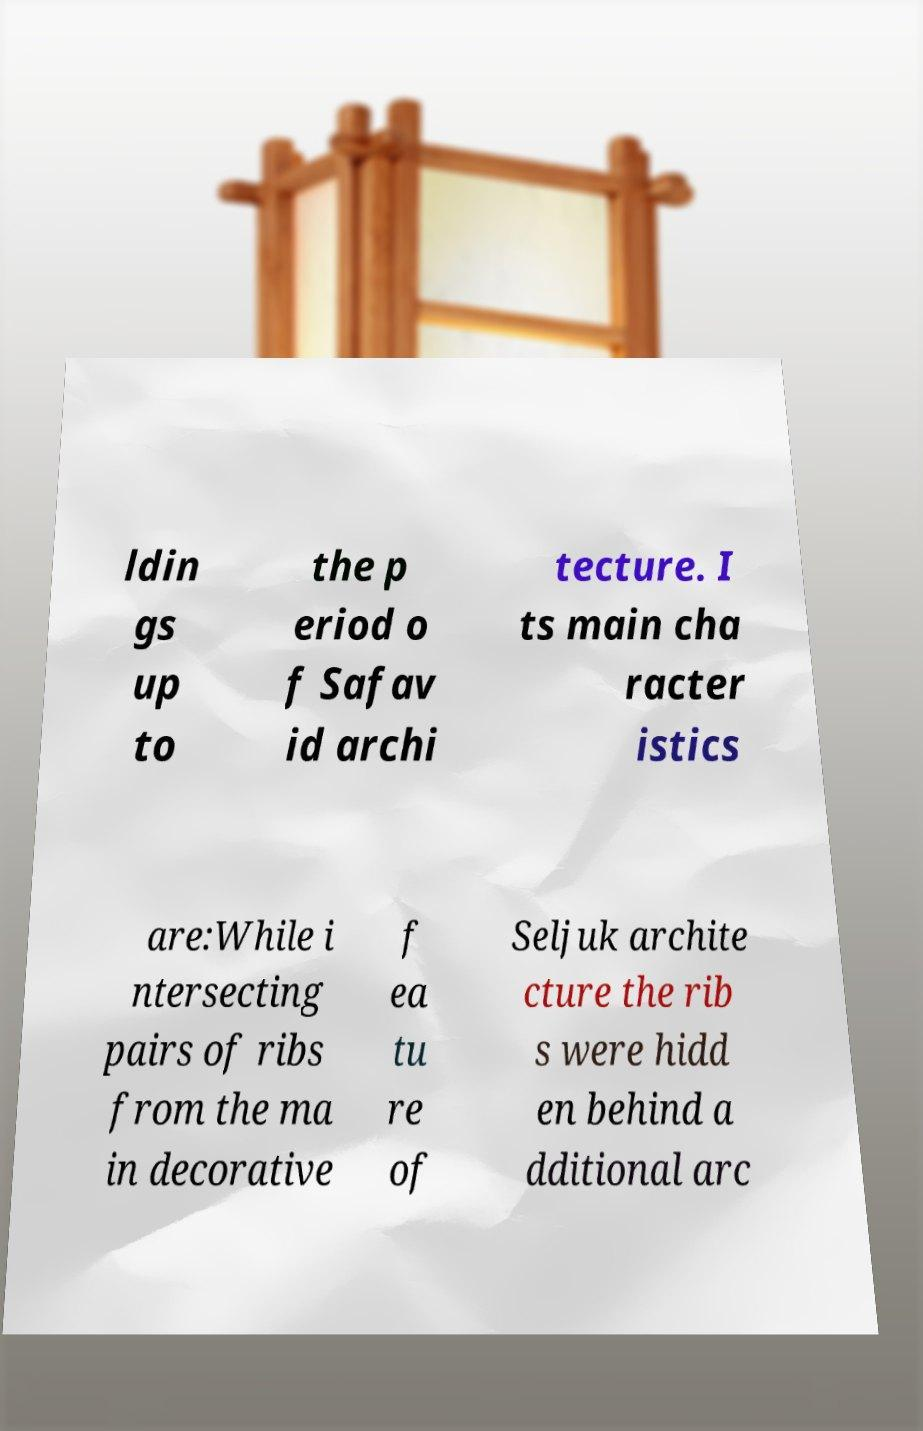Please identify and transcribe the text found in this image. ldin gs up to the p eriod o f Safav id archi tecture. I ts main cha racter istics are:While i ntersecting pairs of ribs from the ma in decorative f ea tu re of Seljuk archite cture the rib s were hidd en behind a dditional arc 